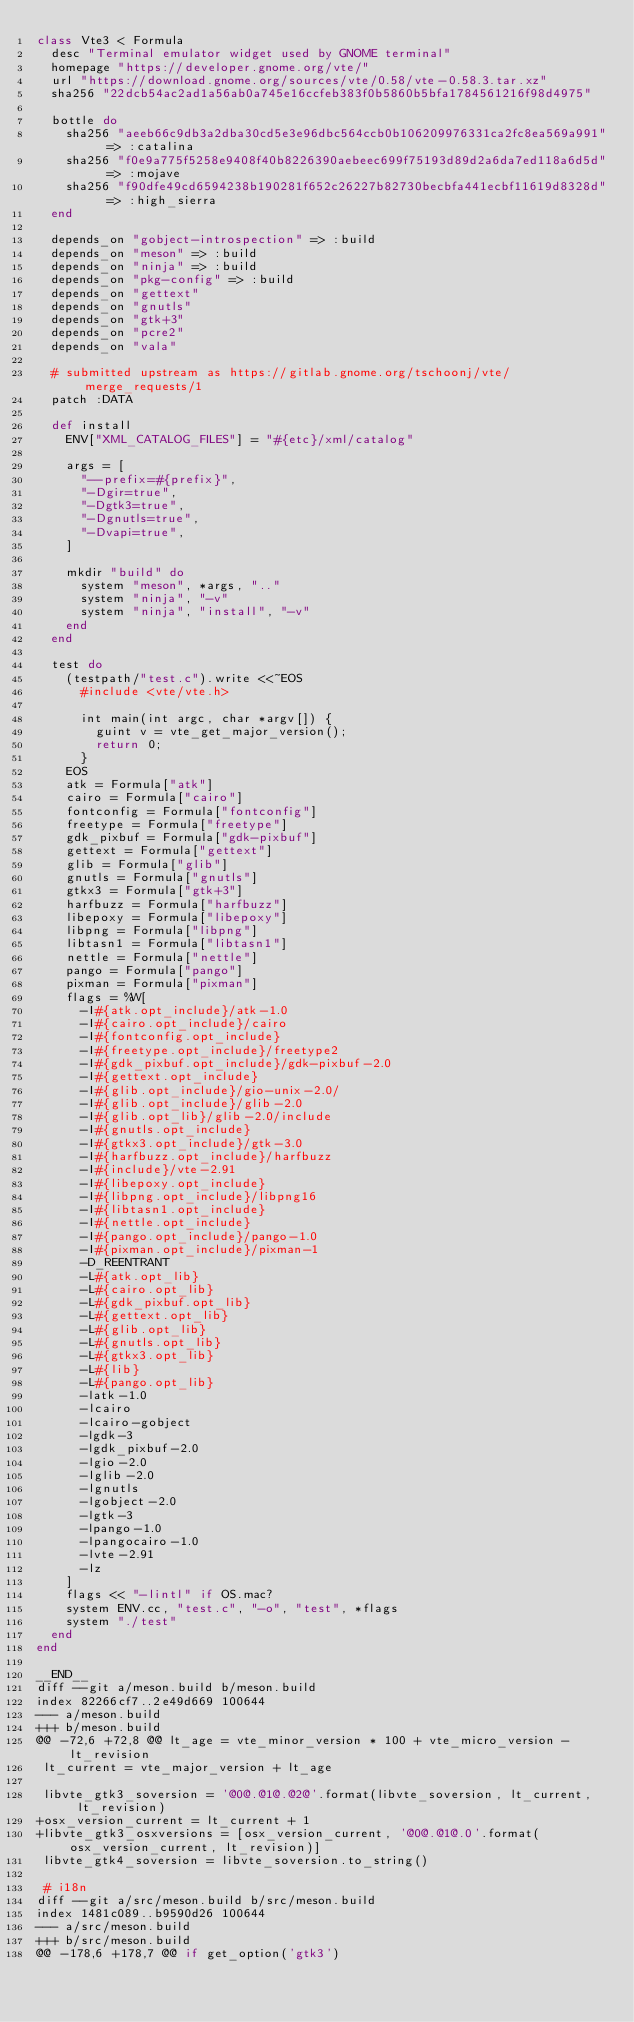<code> <loc_0><loc_0><loc_500><loc_500><_Ruby_>class Vte3 < Formula
  desc "Terminal emulator widget used by GNOME terminal"
  homepage "https://developer.gnome.org/vte/"
  url "https://download.gnome.org/sources/vte/0.58/vte-0.58.3.tar.xz"
  sha256 "22dcb54ac2ad1a56ab0a745e16ccfeb383f0b5860b5bfa1784561216f98d4975"

  bottle do
    sha256 "aeeb66c9db3a2dba30cd5e3e96dbc564ccb0b106209976331ca2fc8ea569a991" => :catalina
    sha256 "f0e9a775f5258e9408f40b8226390aebeec699f75193d89d2a6da7ed118a6d5d" => :mojave
    sha256 "f90dfe49cd6594238b190281f652c26227b82730becbfa441ecbf11619d8328d" => :high_sierra
  end

  depends_on "gobject-introspection" => :build
  depends_on "meson" => :build
  depends_on "ninja" => :build
  depends_on "pkg-config" => :build
  depends_on "gettext"
  depends_on "gnutls"
  depends_on "gtk+3"
  depends_on "pcre2"
  depends_on "vala"

  # submitted upstream as https://gitlab.gnome.org/tschoonj/vte/merge_requests/1
  patch :DATA

  def install
    ENV["XML_CATALOG_FILES"] = "#{etc}/xml/catalog"

    args = [
      "--prefix=#{prefix}",
      "-Dgir=true",
      "-Dgtk3=true",
      "-Dgnutls=true",
      "-Dvapi=true",
    ]

    mkdir "build" do
      system "meson", *args, ".."
      system "ninja", "-v"
      system "ninja", "install", "-v"
    end
  end

  test do
    (testpath/"test.c").write <<~EOS
      #include <vte/vte.h>

      int main(int argc, char *argv[]) {
        guint v = vte_get_major_version();
        return 0;
      }
    EOS
    atk = Formula["atk"]
    cairo = Formula["cairo"]
    fontconfig = Formula["fontconfig"]
    freetype = Formula["freetype"]
    gdk_pixbuf = Formula["gdk-pixbuf"]
    gettext = Formula["gettext"]
    glib = Formula["glib"]
    gnutls = Formula["gnutls"]
    gtkx3 = Formula["gtk+3"]
    harfbuzz = Formula["harfbuzz"]
    libepoxy = Formula["libepoxy"]
    libpng = Formula["libpng"]
    libtasn1 = Formula["libtasn1"]
    nettle = Formula["nettle"]
    pango = Formula["pango"]
    pixman = Formula["pixman"]
    flags = %W[
      -I#{atk.opt_include}/atk-1.0
      -I#{cairo.opt_include}/cairo
      -I#{fontconfig.opt_include}
      -I#{freetype.opt_include}/freetype2
      -I#{gdk_pixbuf.opt_include}/gdk-pixbuf-2.0
      -I#{gettext.opt_include}
      -I#{glib.opt_include}/gio-unix-2.0/
      -I#{glib.opt_include}/glib-2.0
      -I#{glib.opt_lib}/glib-2.0/include
      -I#{gnutls.opt_include}
      -I#{gtkx3.opt_include}/gtk-3.0
      -I#{harfbuzz.opt_include}/harfbuzz
      -I#{include}/vte-2.91
      -I#{libepoxy.opt_include}
      -I#{libpng.opt_include}/libpng16
      -I#{libtasn1.opt_include}
      -I#{nettle.opt_include}
      -I#{pango.opt_include}/pango-1.0
      -I#{pixman.opt_include}/pixman-1
      -D_REENTRANT
      -L#{atk.opt_lib}
      -L#{cairo.opt_lib}
      -L#{gdk_pixbuf.opt_lib}
      -L#{gettext.opt_lib}
      -L#{glib.opt_lib}
      -L#{gnutls.opt_lib}
      -L#{gtkx3.opt_lib}
      -L#{lib}
      -L#{pango.opt_lib}
      -latk-1.0
      -lcairo
      -lcairo-gobject
      -lgdk-3
      -lgdk_pixbuf-2.0
      -lgio-2.0
      -lglib-2.0
      -lgnutls
      -lgobject-2.0
      -lgtk-3
      -lpango-1.0
      -lpangocairo-1.0
      -lvte-2.91
      -lz
    ]
    flags << "-lintl" if OS.mac?
    system ENV.cc, "test.c", "-o", "test", *flags
    system "./test"
  end
end

__END__
diff --git a/meson.build b/meson.build
index 82266cf7..2e49d669 100644
--- a/meson.build
+++ b/meson.build
@@ -72,6 +72,8 @@ lt_age = vte_minor_version * 100 + vte_micro_version - lt_revision
 lt_current = vte_major_version + lt_age

 libvte_gtk3_soversion = '@0@.@1@.@2@'.format(libvte_soversion, lt_current, lt_revision)
+osx_version_current = lt_current + 1
+libvte_gtk3_osxversions = [osx_version_current, '@0@.@1@.0'.format(osx_version_current, lt_revision)]
 libvte_gtk4_soversion = libvte_soversion.to_string()

 # i18n
diff --git a/src/meson.build b/src/meson.build
index 1481c089..b9590d26 100644
--- a/src/meson.build
+++ b/src/meson.build
@@ -178,6 +178,7 @@ if get_option('gtk3')</code> 